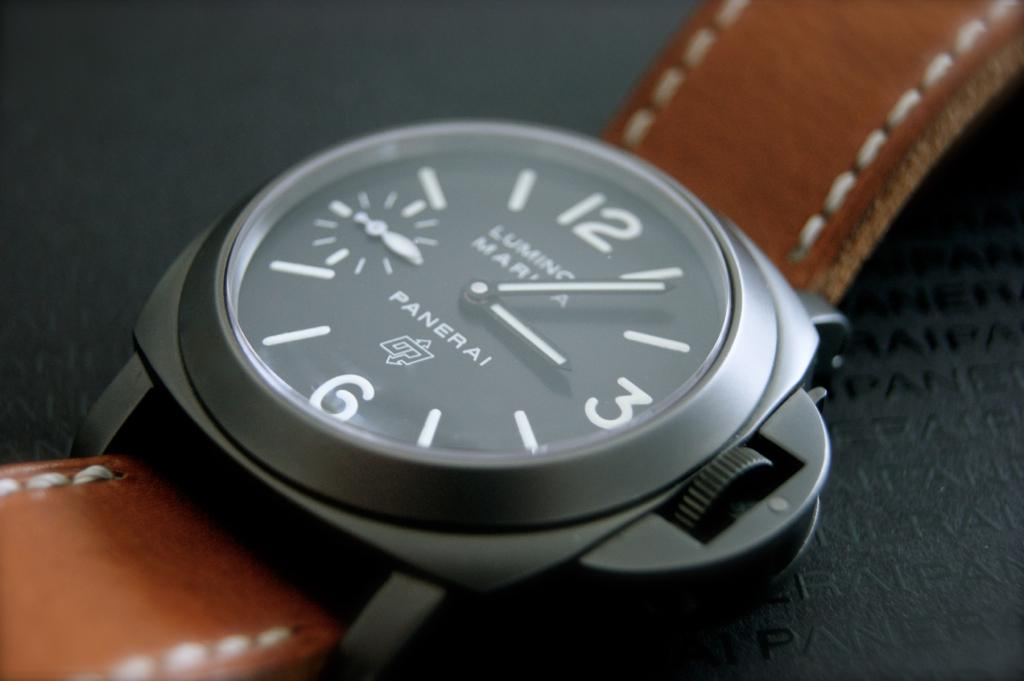What features make this watch unique? The watch has several notable features, including a large, minimalist dial with luminous hands and markers for easy reading in low light, a cushion-shaped case characteristic of Panerai designs, and a wide, distinctive bezel. The brown leather strap complements its bold yet classic style. 